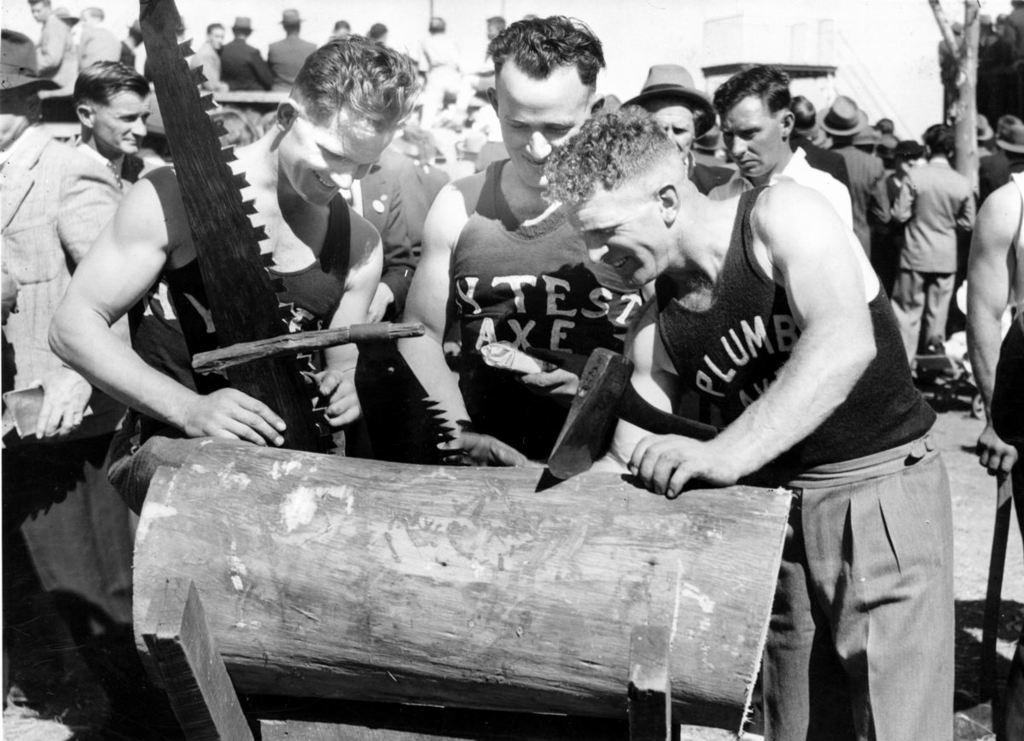What is the color scheme of the image? The image is black and white. What is the main subject in the center of the image? There are many persons standing at the wood in the center of the image. Can you describe the background of the image? There are persons visible in the background of the image, along with at least one building and trees. What type of food is being served at the scene in the image? There is no food visible in the image, and the term "scene" is not applicable as it implies a staged or fictional setting, which is not suggested by the provided facts. 